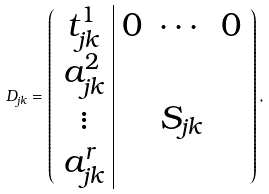Convert formula to latex. <formula><loc_0><loc_0><loc_500><loc_500>D _ { j k } = \left ( \begin{array} { c | c c c } t _ { j k } ^ { 1 } & 0 & \cdots & 0 \\ a _ { j k } ^ { 2 } & & & \\ \vdots & & S _ { j k } & \\ a _ { j k } ^ { r } & & & \end{array} \right ) ,</formula> 